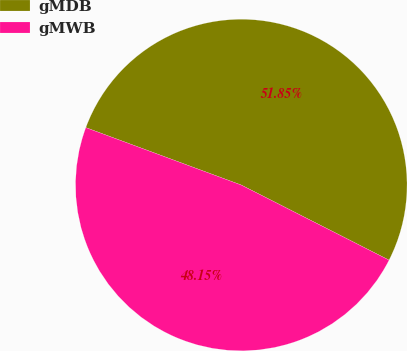Convert chart to OTSL. <chart><loc_0><loc_0><loc_500><loc_500><pie_chart><fcel>gMDB<fcel>gMWB<nl><fcel>51.85%<fcel>48.15%<nl></chart> 